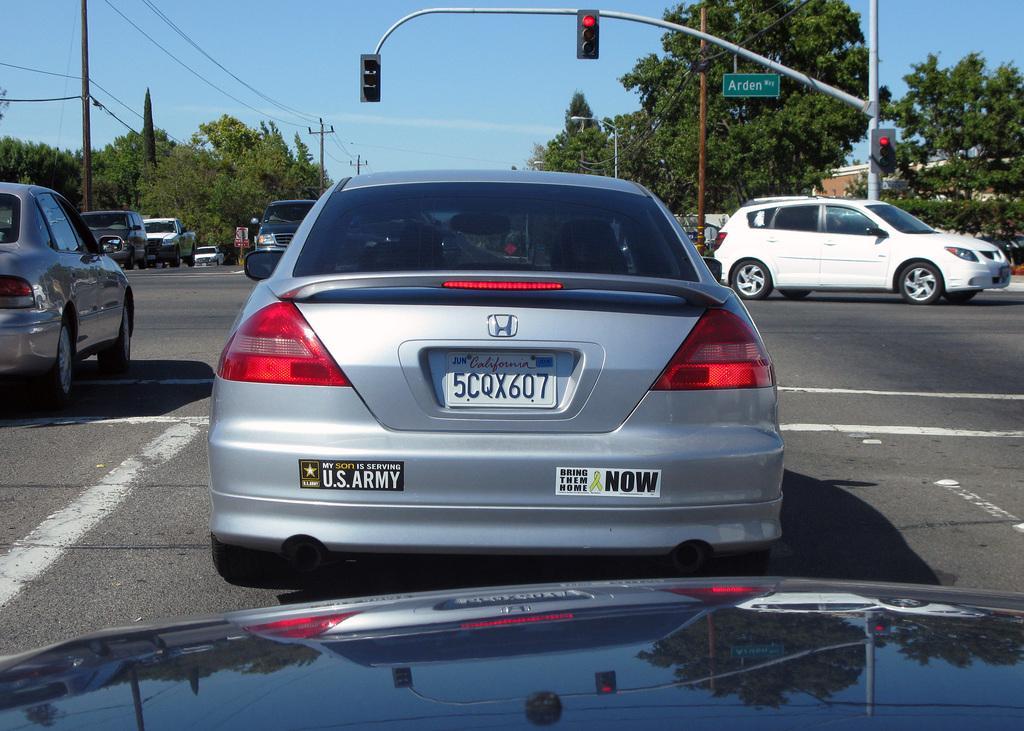In one or two sentences, can you explain what this image depicts? In this image there are cars on the road. In the background there are trees, poles and there are wires. 